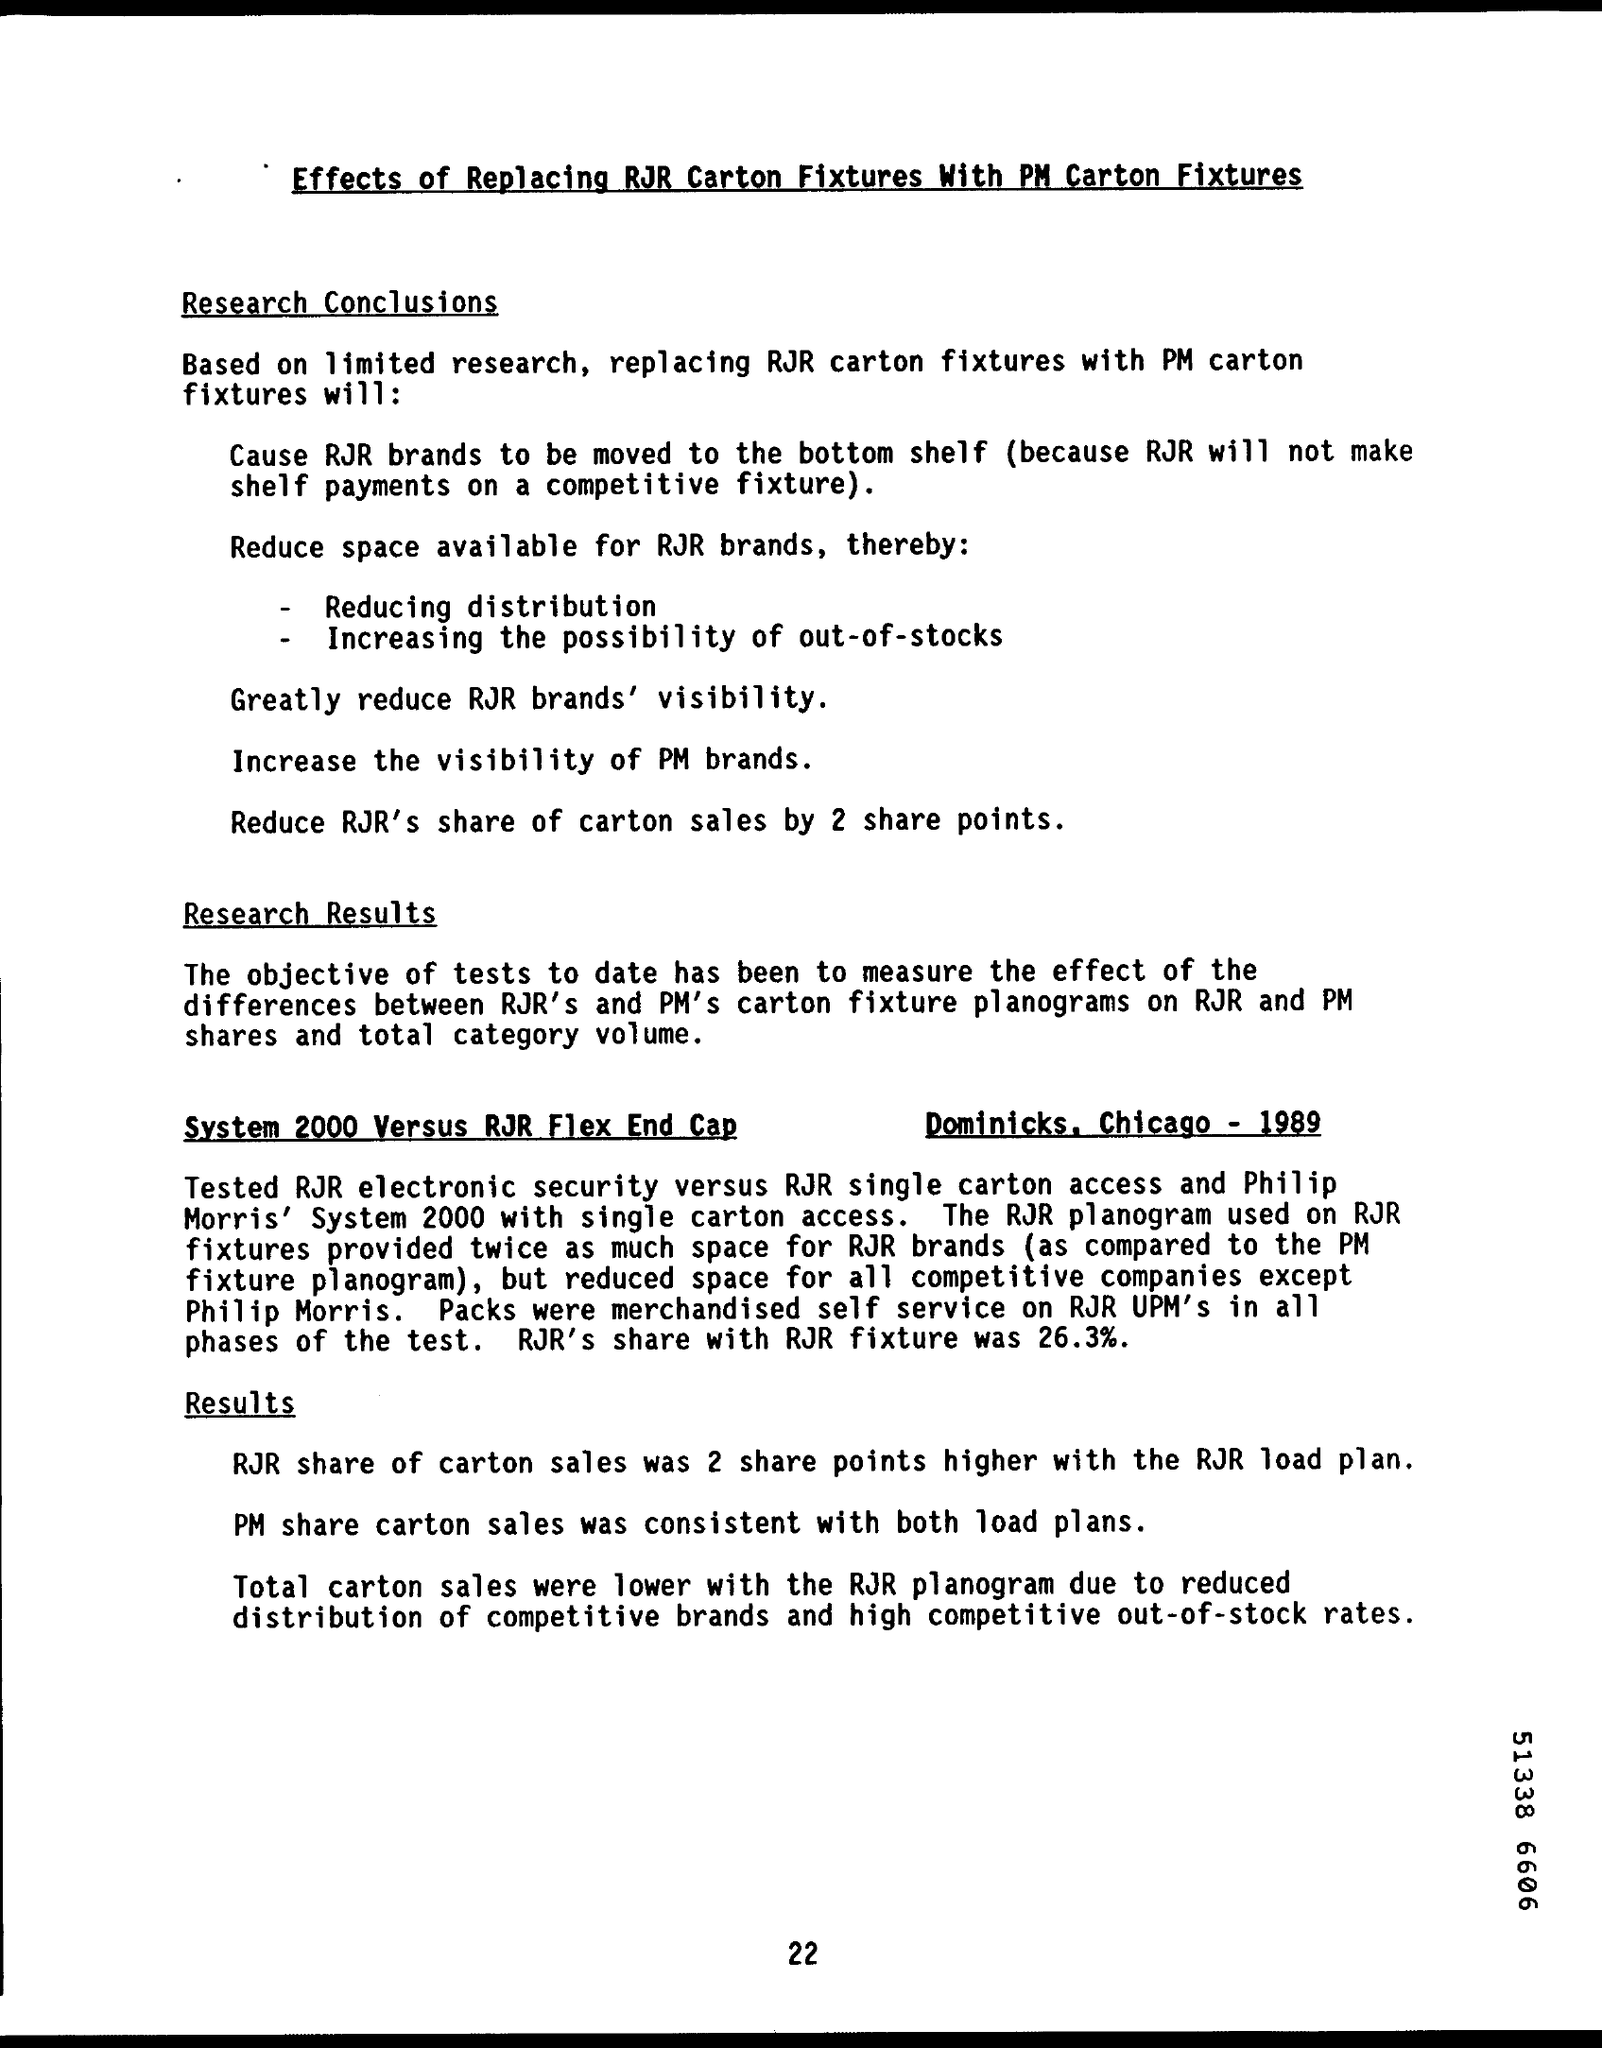What is the document title?
Your answer should be compact. Effects of Replacing RJR Carton Fixtures With PM Carton Fixtures. What is the page number on this document?
Offer a very short reply. 22. What was RJR's share with RJR fixture?
Provide a short and direct response. 26.3%. 